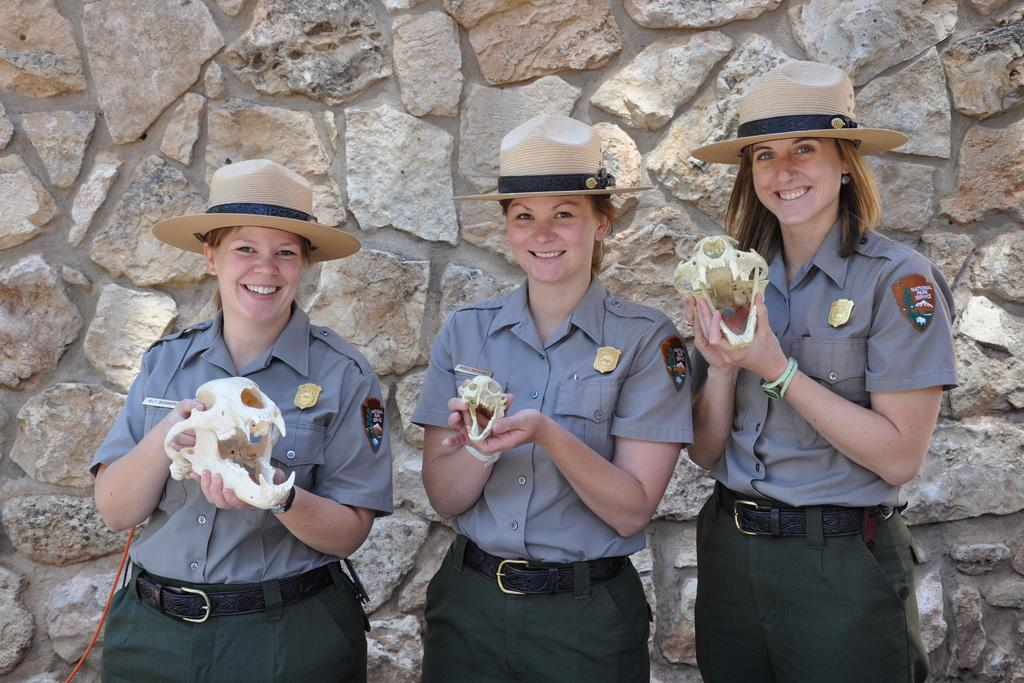How many people are in the image? There are three women in the image. What are the women doing in the image? The women are standing and smiling. What objects are the women holding in the image? The women are holding skulls. What can be seen in the background of the image? There is a wall in the background of the image. What type of division is taking place in the image? There is no division taking place in the image; it features three women holding skulls. What type of play is depicted in the image? There is no play depicted in the image; it features three women holding skulls. 